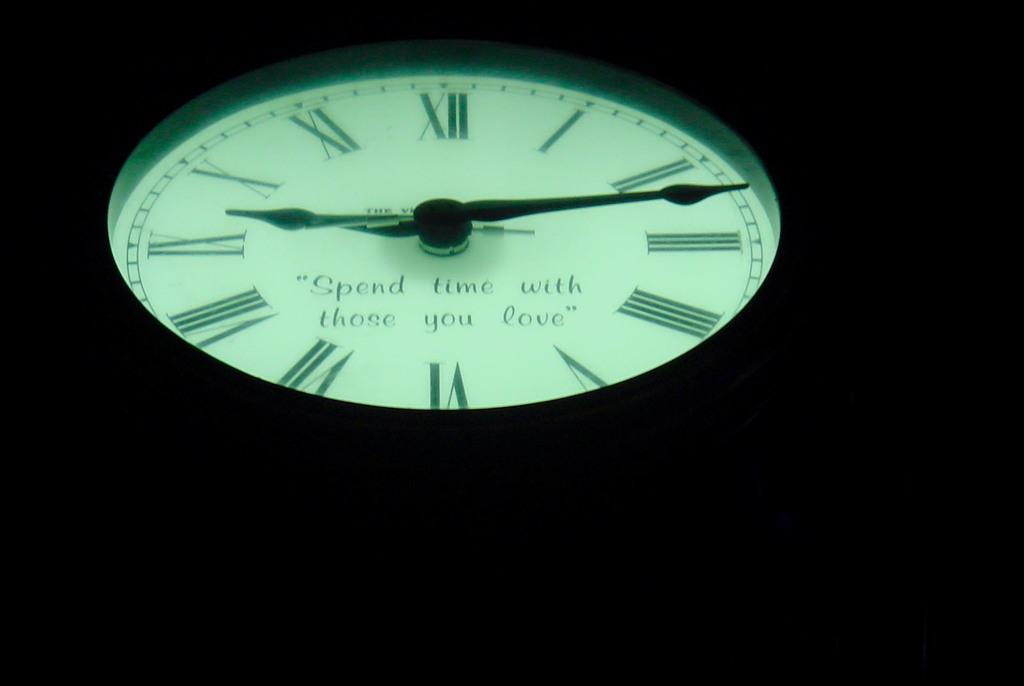<image>
Create a compact narrative representing the image presented. White face of a watch which says "Spend time with those you love". 